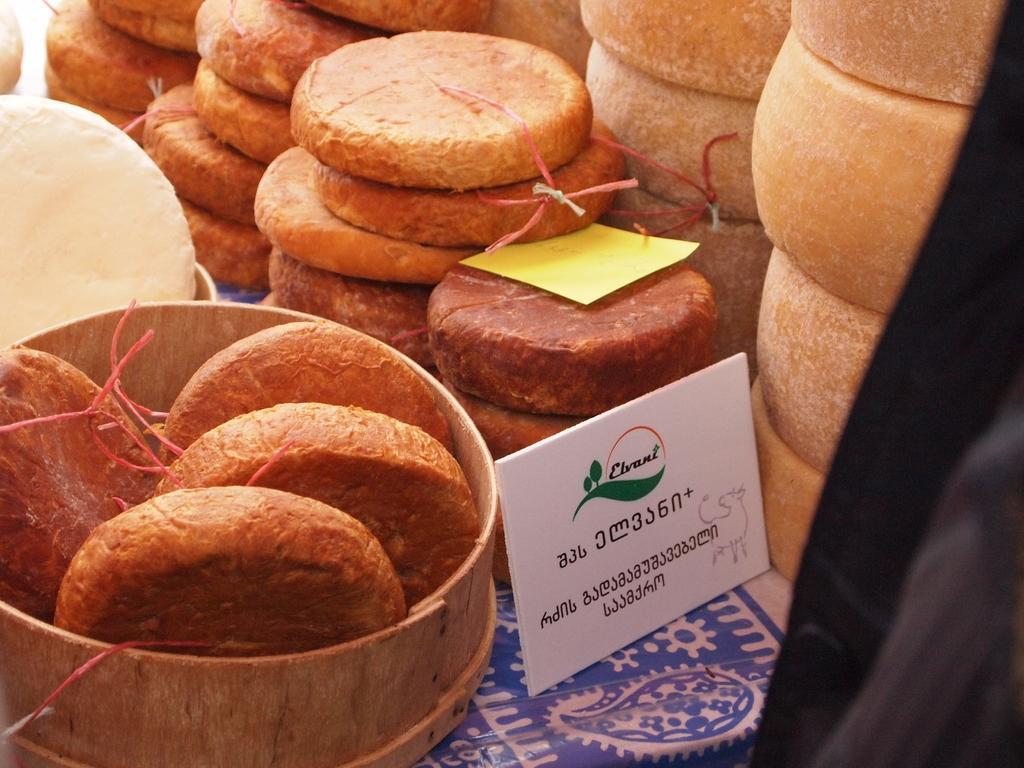Could you give a brief overview of what you see in this image? In this image we can see some food items on the cloth, and some food items in the bowl, there is a board with text near the food items and a yellow color object looks like paper on the food item. 